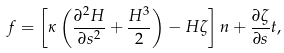Convert formula to latex. <formula><loc_0><loc_0><loc_500><loc_500>f = \left [ \kappa \left ( \frac { \partial ^ { 2 } H } { \partial s ^ { 2 } } + \frac { H ^ { 3 } } { 2 } \right ) - H \zeta \right ] n + \frac { \partial \zeta } { \partial s } t ,</formula> 